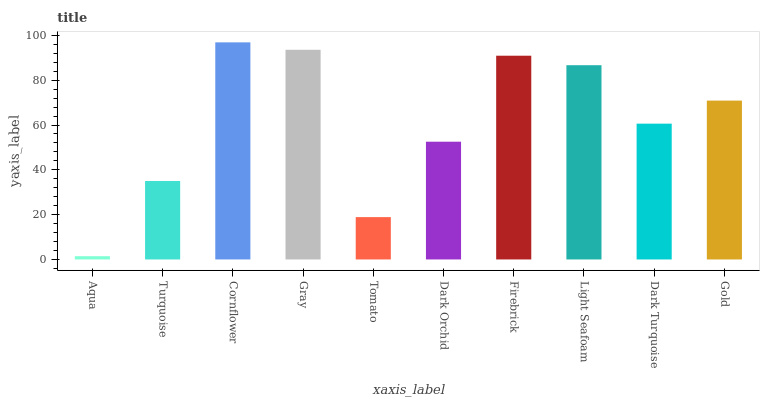Is Aqua the minimum?
Answer yes or no. Yes. Is Cornflower the maximum?
Answer yes or no. Yes. Is Turquoise the minimum?
Answer yes or no. No. Is Turquoise the maximum?
Answer yes or no. No. Is Turquoise greater than Aqua?
Answer yes or no. Yes. Is Aqua less than Turquoise?
Answer yes or no. Yes. Is Aqua greater than Turquoise?
Answer yes or no. No. Is Turquoise less than Aqua?
Answer yes or no. No. Is Gold the high median?
Answer yes or no. Yes. Is Dark Turquoise the low median?
Answer yes or no. Yes. Is Cornflower the high median?
Answer yes or no. No. Is Turquoise the low median?
Answer yes or no. No. 